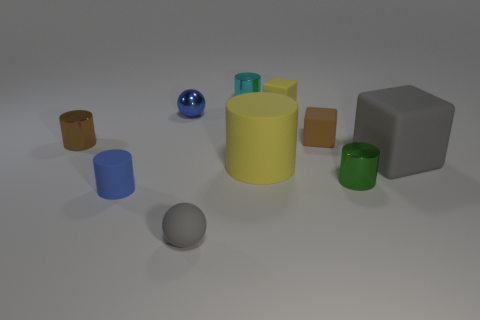How many things are gray things or brown matte blocks?
Your answer should be very brief. 3. What shape is the thing that is the same color as the tiny rubber sphere?
Keep it short and to the point. Cube. There is a shiny thing that is both in front of the blue metal sphere and left of the small gray thing; what size is it?
Provide a short and direct response. Small. What number of small cyan metal spheres are there?
Give a very brief answer. 0. How many balls are large green things or blue objects?
Your answer should be very brief. 1. There is a small cylinder right of the small brown thing to the right of the tiny cyan metallic cylinder; what number of large gray rubber objects are in front of it?
Provide a succinct answer. 0. The other ball that is the same size as the gray matte ball is what color?
Offer a terse response. Blue. How many other things are there of the same color as the rubber ball?
Your response must be concise. 1. Are there more small cylinders to the right of the yellow matte cube than tiny brown matte blocks?
Make the answer very short. No. Do the tiny brown cube and the small blue cylinder have the same material?
Your answer should be compact. Yes. 